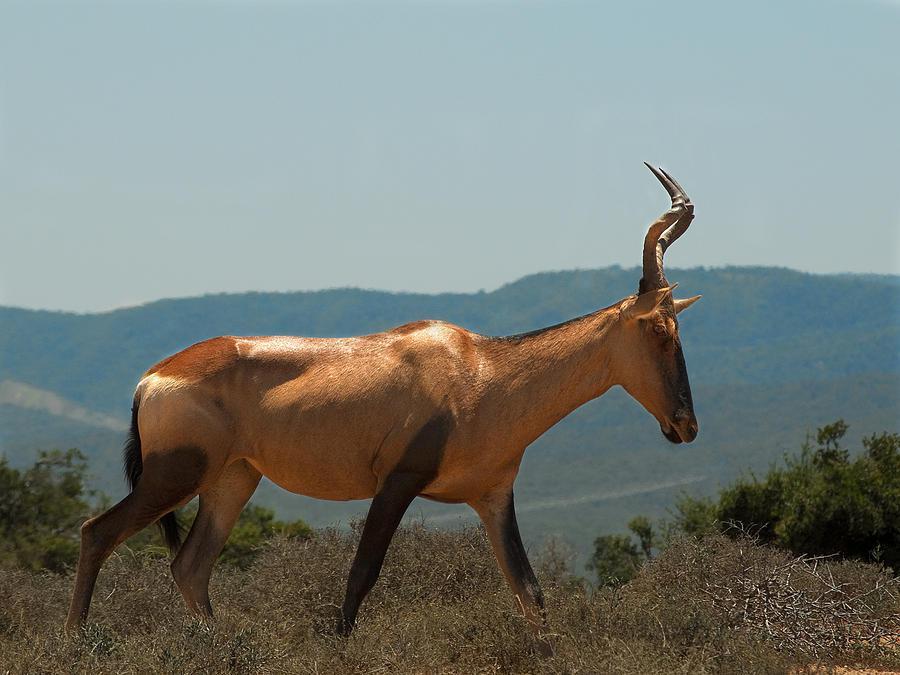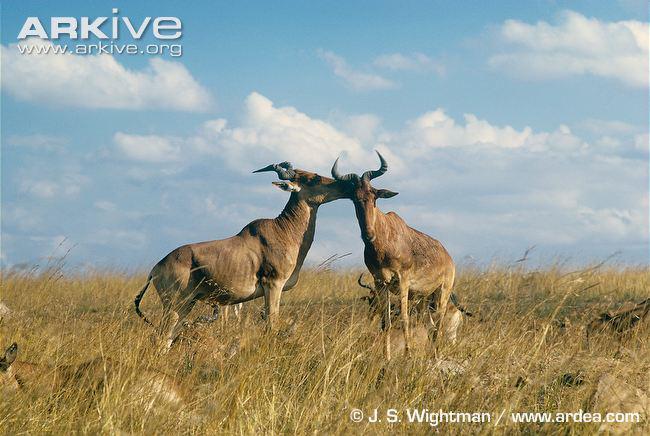The first image is the image on the left, the second image is the image on the right. For the images shown, is this caption "There are exactly three goats." true? Answer yes or no. Yes. The first image is the image on the left, the second image is the image on the right. For the images shown, is this caption "One image contains two upright horned animals engaged in physical contact, and the other image contains one horned animal standing in profile." true? Answer yes or no. Yes. 